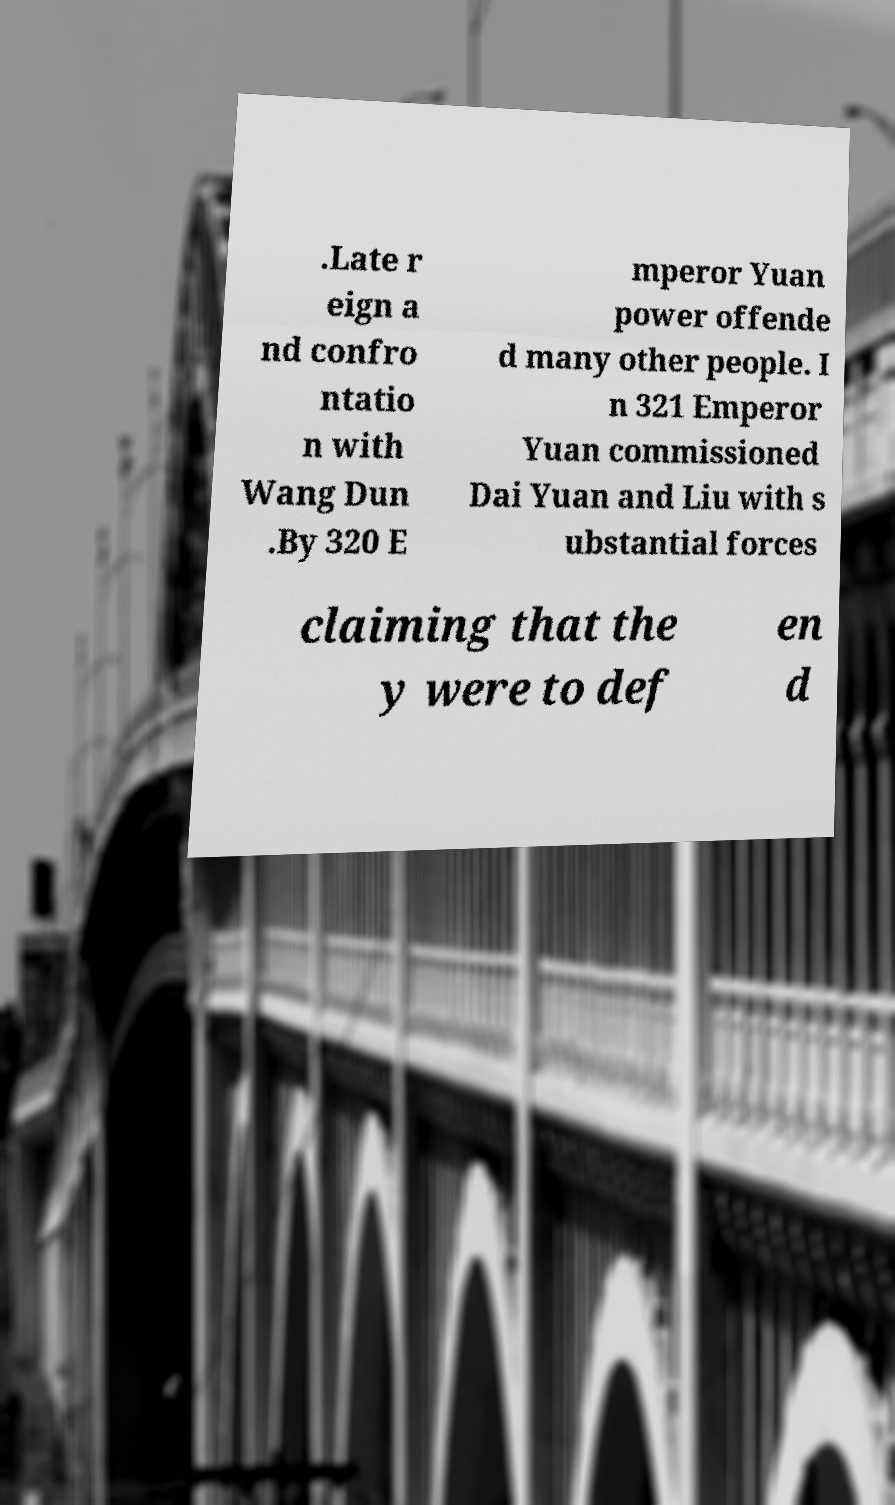What messages or text are displayed in this image? I need them in a readable, typed format. .Late r eign a nd confro ntatio n with Wang Dun .By 320 E mperor Yuan power offende d many other people. I n 321 Emperor Yuan commissioned Dai Yuan and Liu with s ubstantial forces claiming that the y were to def en d 